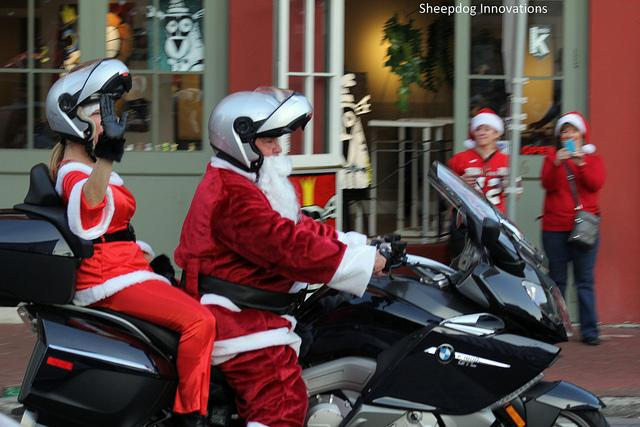Who is riding on the motorcycle? Please explain your reasoning. santa claus. Santa is wearing his red suit. 